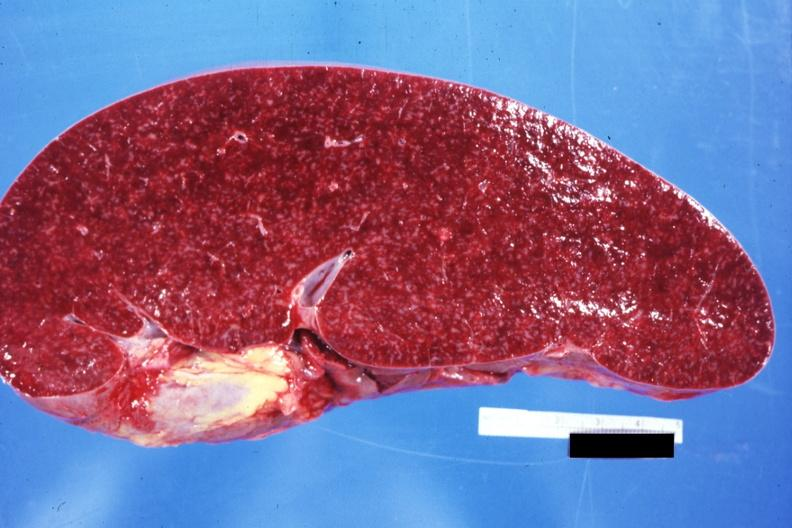s lymphoma present?
Answer the question using a single word or phrase. Yes 